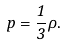Convert formula to latex. <formula><loc_0><loc_0><loc_500><loc_500>p = \frac { 1 } { 3 } \rho .</formula> 